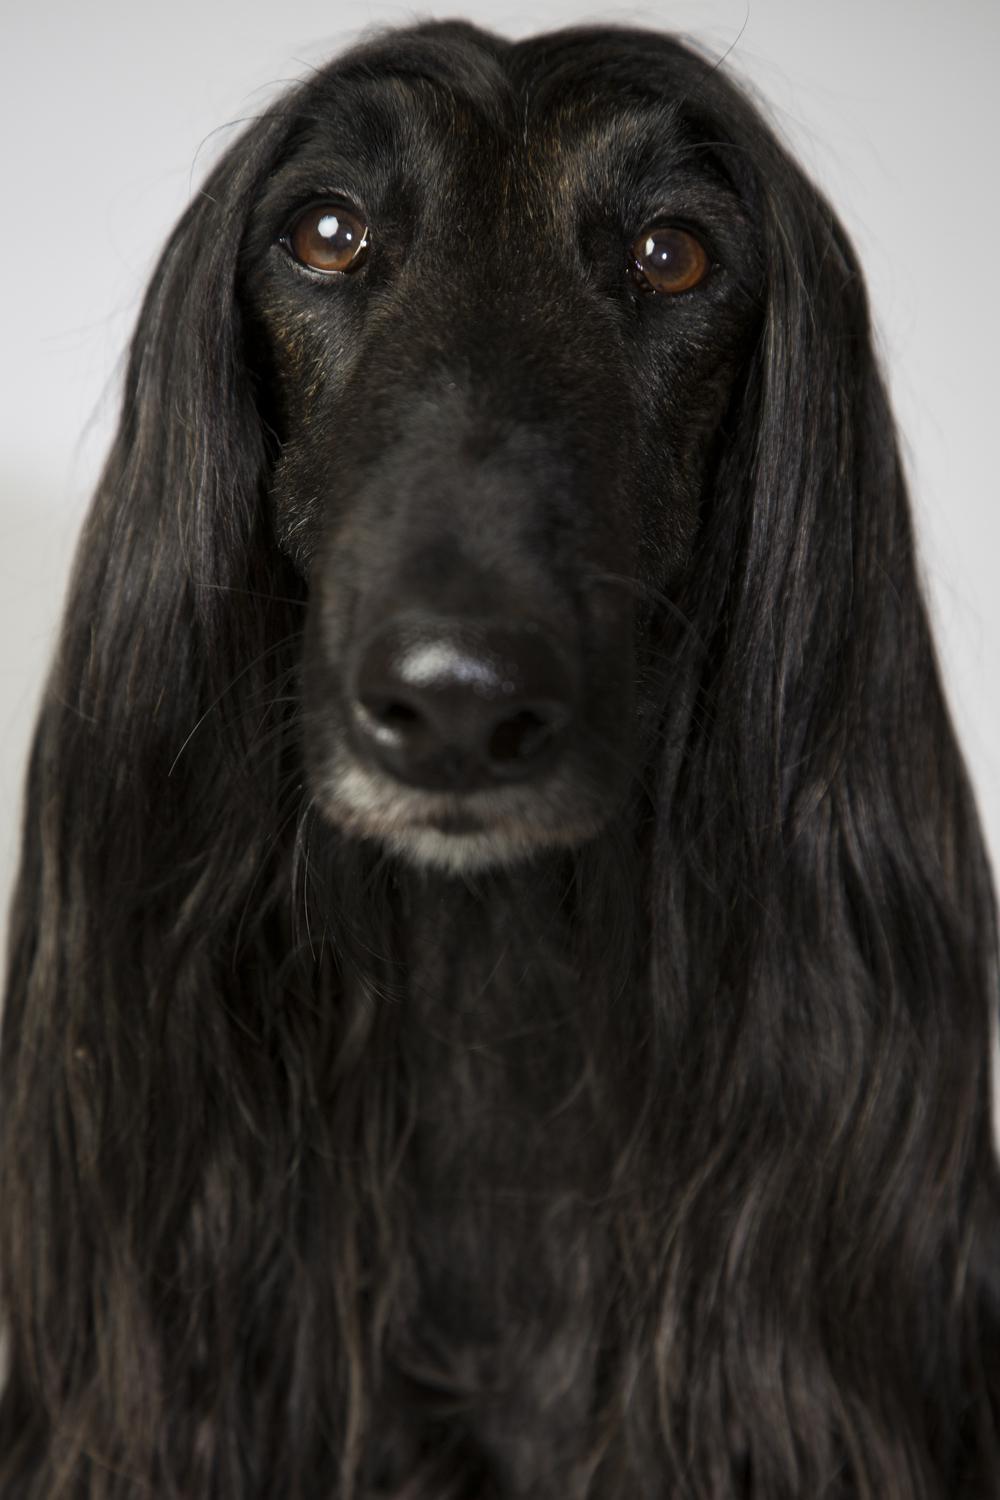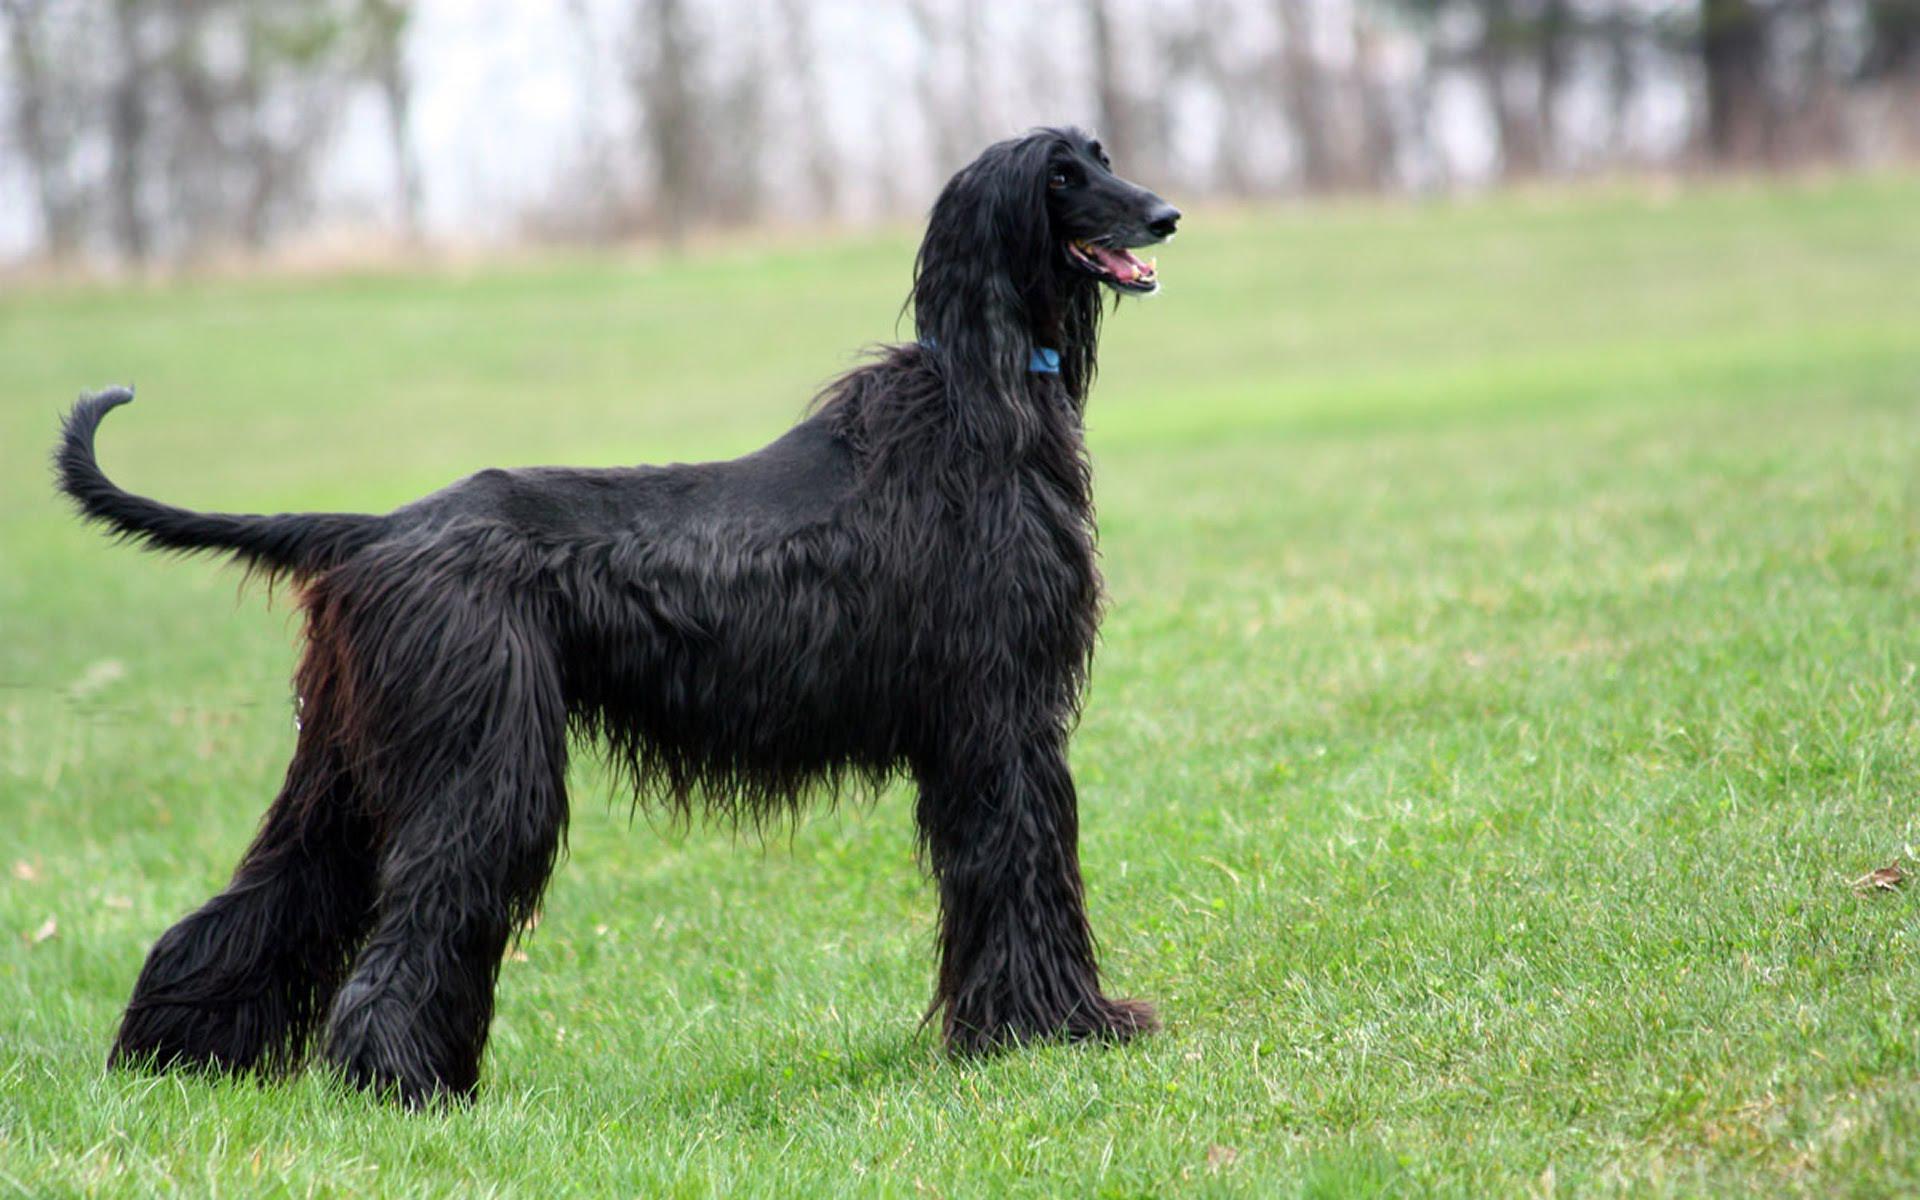The first image is the image on the left, the second image is the image on the right. Evaluate the accuracy of this statement regarding the images: "Exactly one dog is on the grass.". Is it true? Answer yes or no. Yes. The first image is the image on the left, the second image is the image on the right. Analyze the images presented: Is the assertion "The left and right image contains the same number of dogs face left forward." valid? Answer yes or no. No. 